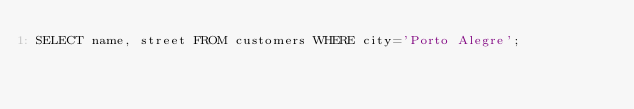<code> <loc_0><loc_0><loc_500><loc_500><_SQL_>SELECT name, street FROM customers WHERE city='Porto Alegre';
</code> 